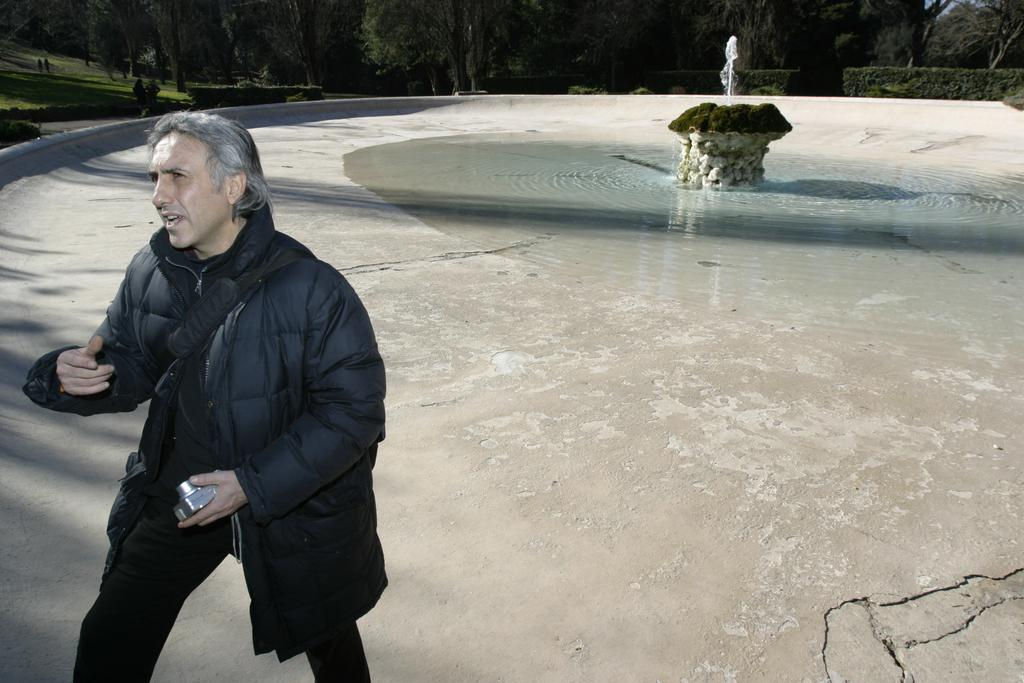What are the people in the image doing? The people are standing on the ground and holding a camera. What can be seen in the image besides the people? There is a fountain in the image, and grass is present on the ground. What is the fountain doing? Water is visible in the fountain. What type of vegetation is at the back of the image? There are trees at the back of the image. How many spiders are crawling on the camera in the image? There are no spiders present in the image; the people are holding a camera. What type of shock can be seen in the image? There is no shock present in the image; it features people holding a camera near a fountain and trees. 